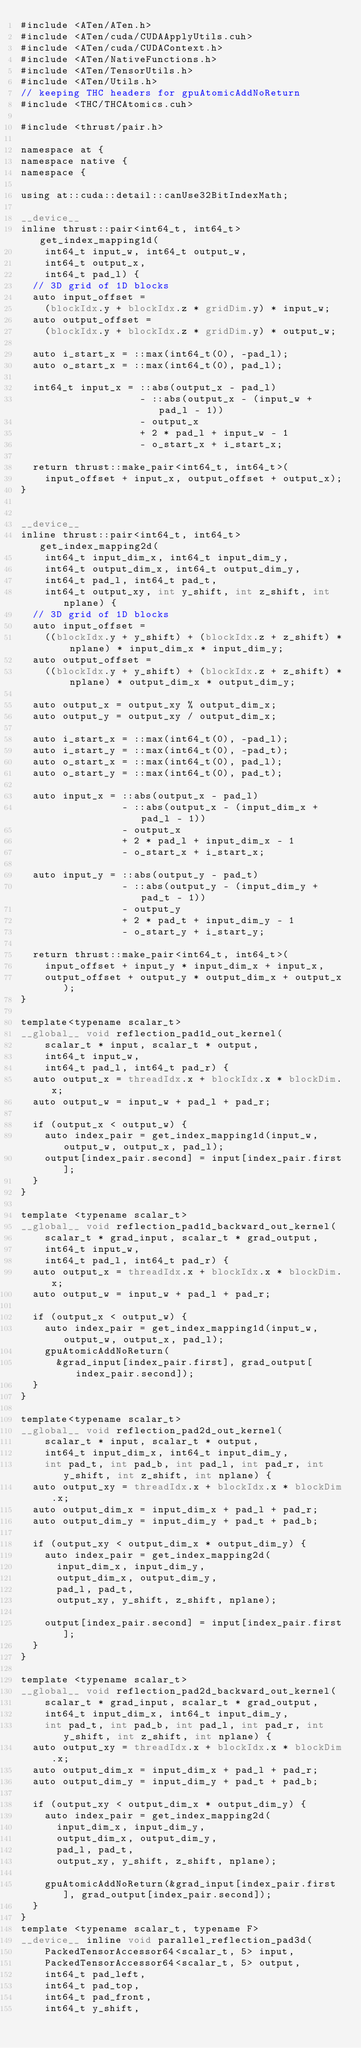<code> <loc_0><loc_0><loc_500><loc_500><_Cuda_>#include <ATen/ATen.h>
#include <ATen/cuda/CUDAApplyUtils.cuh>
#include <ATen/cuda/CUDAContext.h>
#include <ATen/NativeFunctions.h>
#include <ATen/TensorUtils.h>
#include <ATen/Utils.h>
// keeping THC headers for gpuAtomicAddNoReturn
#include <THC/THCAtomics.cuh>

#include <thrust/pair.h>

namespace at {
namespace native {
namespace {

using at::cuda::detail::canUse32BitIndexMath;

__device__
inline thrust::pair<int64_t, int64_t> get_index_mapping1d(
    int64_t input_w, int64_t output_w,
    int64_t output_x,
    int64_t pad_l) {
  // 3D grid of 1D blocks
  auto input_offset =
    (blockIdx.y + blockIdx.z * gridDim.y) * input_w;
  auto output_offset =
    (blockIdx.y + blockIdx.z * gridDim.y) * output_w;

  auto i_start_x = ::max(int64_t(0), -pad_l);
  auto o_start_x = ::max(int64_t(0), pad_l);

  int64_t input_x = ::abs(output_x - pad_l)
                    - ::abs(output_x - (input_w + pad_l - 1))
                    - output_x
                    + 2 * pad_l + input_w - 1
                    - o_start_x + i_start_x;

  return thrust::make_pair<int64_t, int64_t>(
    input_offset + input_x, output_offset + output_x);
}


__device__
inline thrust::pair<int64_t, int64_t>  get_index_mapping2d(
    int64_t input_dim_x, int64_t input_dim_y,
    int64_t output_dim_x, int64_t output_dim_y,
    int64_t pad_l, int64_t pad_t,
    int64_t output_xy, int y_shift, int z_shift, int nplane) {
  // 3D grid of 1D blocks
  auto input_offset =
    ((blockIdx.y + y_shift) + (blockIdx.z + z_shift) * nplane) * input_dim_x * input_dim_y;
  auto output_offset =
    ((blockIdx.y + y_shift) + (blockIdx.z + z_shift) * nplane) * output_dim_x * output_dim_y;

  auto output_x = output_xy % output_dim_x;
  auto output_y = output_xy / output_dim_x;

  auto i_start_x = ::max(int64_t(0), -pad_l);
  auto i_start_y = ::max(int64_t(0), -pad_t);
  auto o_start_x = ::max(int64_t(0), pad_l);
  auto o_start_y = ::max(int64_t(0), pad_t);

  auto input_x = ::abs(output_x - pad_l)
                 - ::abs(output_x - (input_dim_x + pad_l - 1))
                 - output_x
                 + 2 * pad_l + input_dim_x - 1
                 - o_start_x + i_start_x;

  auto input_y = ::abs(output_y - pad_t)
                 - ::abs(output_y - (input_dim_y + pad_t - 1))
                 - output_y
                 + 2 * pad_t + input_dim_y - 1
                 - o_start_y + i_start_y;

  return thrust::make_pair<int64_t, int64_t>(
    input_offset + input_y * input_dim_x + input_x,
    output_offset + output_y * output_dim_x + output_x);
}

template<typename scalar_t>
__global__ void reflection_pad1d_out_kernel(
    scalar_t * input, scalar_t * output,
    int64_t input_w,
    int64_t pad_l, int64_t pad_r) {
  auto output_x = threadIdx.x + blockIdx.x * blockDim.x;
  auto output_w = input_w + pad_l + pad_r;

  if (output_x < output_w) {
    auto index_pair = get_index_mapping1d(input_w, output_w, output_x, pad_l);
    output[index_pair.second] = input[index_pair.first];
  }
}

template <typename scalar_t>
__global__ void reflection_pad1d_backward_out_kernel(
    scalar_t * grad_input, scalar_t * grad_output,
    int64_t input_w,
    int64_t pad_l, int64_t pad_r) {
  auto output_x = threadIdx.x + blockIdx.x * blockDim.x;
  auto output_w = input_w + pad_l + pad_r;

  if (output_x < output_w) {
    auto index_pair = get_index_mapping1d(input_w, output_w, output_x, pad_l);
    gpuAtomicAddNoReturn(
      &grad_input[index_pair.first], grad_output[index_pair.second]);
  }
}

template<typename scalar_t>
__global__ void reflection_pad2d_out_kernel(
    scalar_t * input, scalar_t * output,
    int64_t input_dim_x, int64_t input_dim_y,
    int pad_t, int pad_b, int pad_l, int pad_r, int y_shift, int z_shift, int nplane) {
  auto output_xy = threadIdx.x + blockIdx.x * blockDim.x;
  auto output_dim_x = input_dim_x + pad_l + pad_r;
  auto output_dim_y = input_dim_y + pad_t + pad_b;

  if (output_xy < output_dim_x * output_dim_y) {
    auto index_pair = get_index_mapping2d(
      input_dim_x, input_dim_y,
      output_dim_x, output_dim_y,
      pad_l, pad_t,
      output_xy, y_shift, z_shift, nplane);

    output[index_pair.second] = input[index_pair.first];
  }
}

template <typename scalar_t>
__global__ void reflection_pad2d_backward_out_kernel(
    scalar_t * grad_input, scalar_t * grad_output,
    int64_t input_dim_x, int64_t input_dim_y,
    int pad_t, int pad_b, int pad_l, int pad_r, int y_shift, int z_shift, int nplane) {
  auto output_xy = threadIdx.x + blockIdx.x * blockDim.x;
  auto output_dim_x = input_dim_x + pad_l + pad_r;
  auto output_dim_y = input_dim_y + pad_t + pad_b;

  if (output_xy < output_dim_x * output_dim_y) {
    auto index_pair = get_index_mapping2d(
      input_dim_x, input_dim_y,
      output_dim_x, output_dim_y,
      pad_l, pad_t,
      output_xy, y_shift, z_shift, nplane);

    gpuAtomicAddNoReturn(&grad_input[index_pair.first], grad_output[index_pair.second]);
  }
}
template <typename scalar_t, typename F>
__device__ inline void parallel_reflection_pad3d(
    PackedTensorAccessor64<scalar_t, 5> input,
    PackedTensorAccessor64<scalar_t, 5> output,
    int64_t pad_left,
    int64_t pad_top,
    int64_t pad_front,
    int64_t y_shift,</code> 